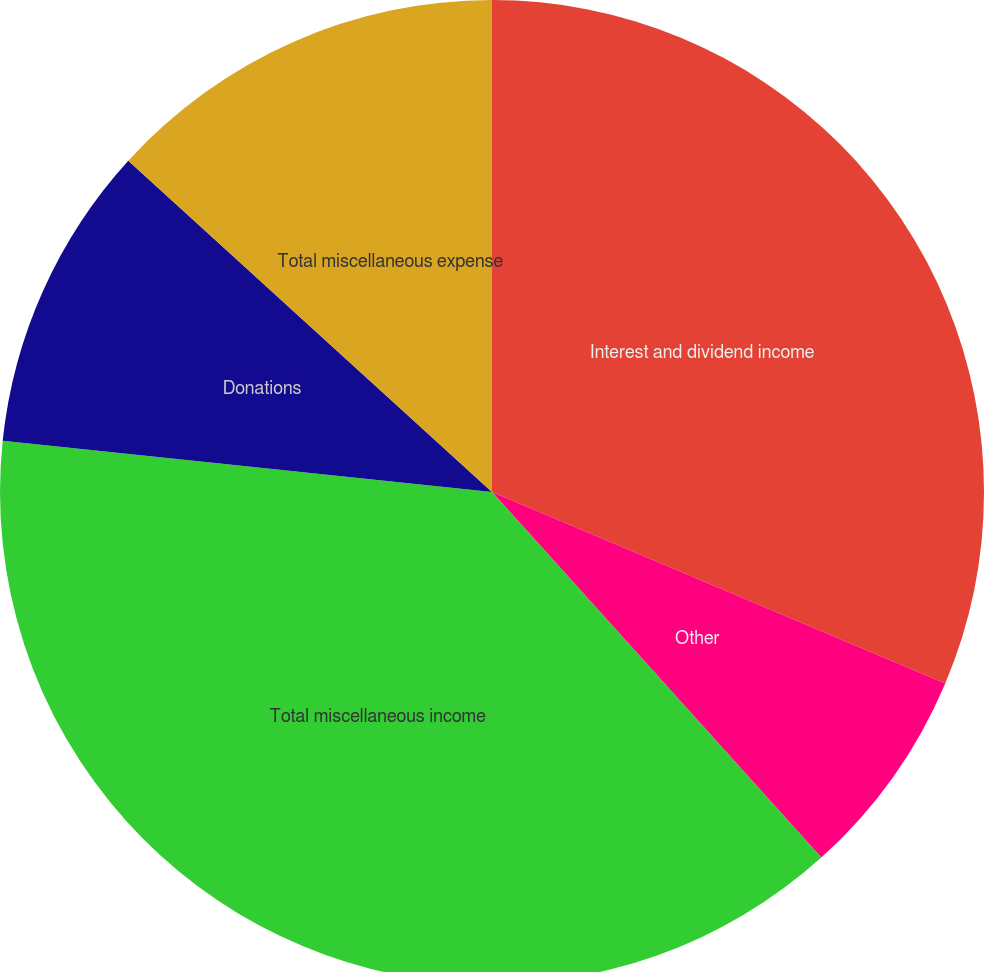<chart> <loc_0><loc_0><loc_500><loc_500><pie_chart><fcel>Interest and dividend income<fcel>Other<fcel>Total miscellaneous income<fcel>Donations<fcel>Total miscellaneous expense<nl><fcel>31.36%<fcel>6.97%<fcel>38.33%<fcel>10.1%<fcel>13.24%<nl></chart> 